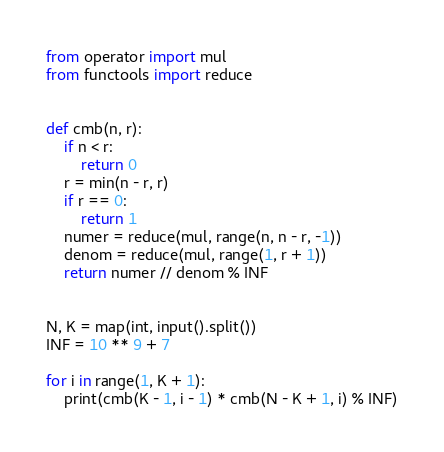Convert code to text. <code><loc_0><loc_0><loc_500><loc_500><_Python_>from operator import mul
from functools import reduce


def cmb(n, r):
	if n < r:
		return 0
	r = min(n - r, r)
	if r == 0:
		return 1
	numer = reduce(mul, range(n, n - r, -1))
	denom = reduce(mul, range(1, r + 1))
	return numer // denom % INF


N, K = map(int, input().split())
INF = 10 ** 9 + 7

for i in range(1, K + 1):
	print(cmb(K - 1, i - 1) * cmb(N - K + 1, i) % INF)
</code> 